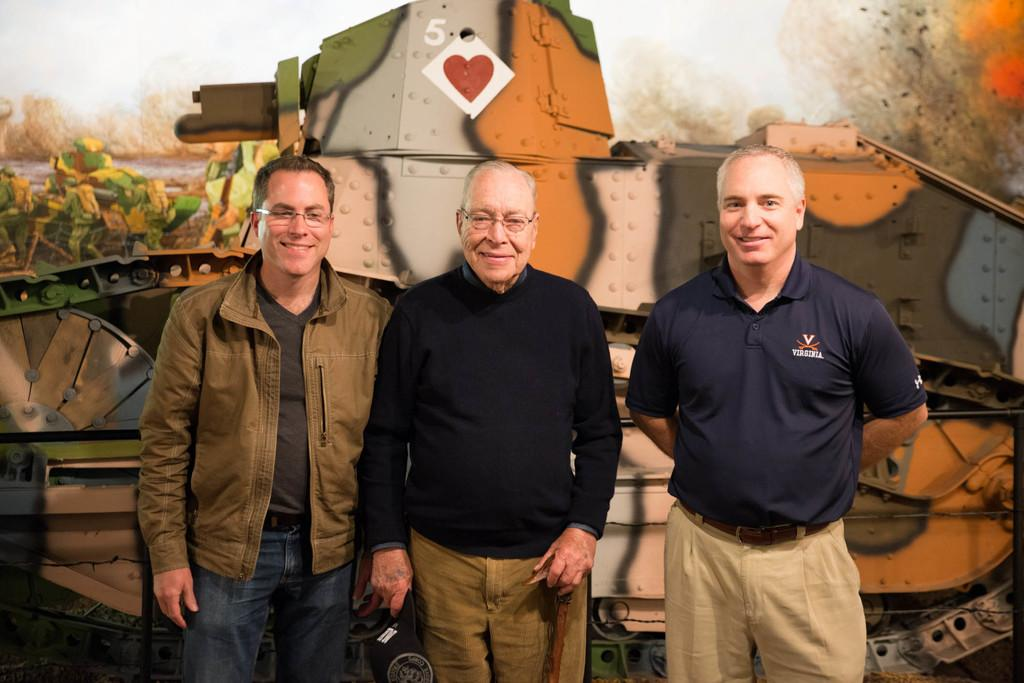How many people are in the image? There are three men in the image. What are the men doing in the image? The men are standing and smiling. What can be seen in the background of the image? There is a painting of a tank in the background of the image. What type of orange is being peeled by one of the men in the image? There is no orange present in the image; the men are not peeling any fruit. What kind of experience do the men have with tanks, given the painting in the background? The image does not provide any information about the men's experiences with tanks, as it only shows a painting of a tank in the background. 